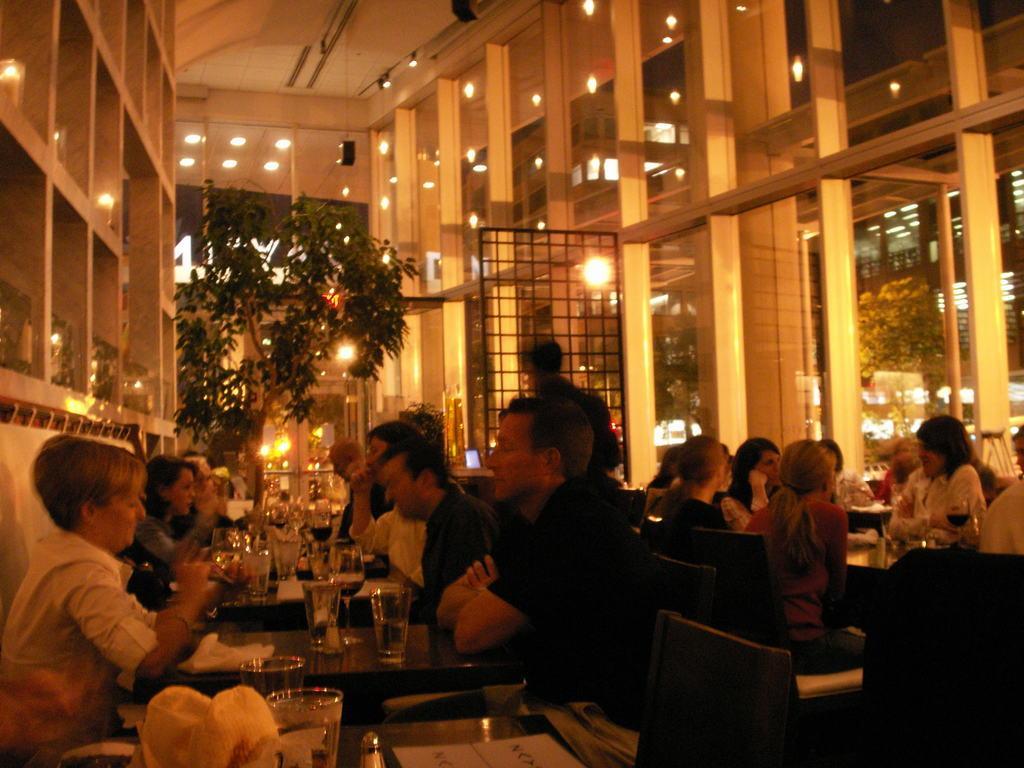Can you describe this image briefly? In this image I can see the group of people siting on the chairs. I can see the table in-front of these people. On the table there are glasses. In the background I can see the plant and many lights. 